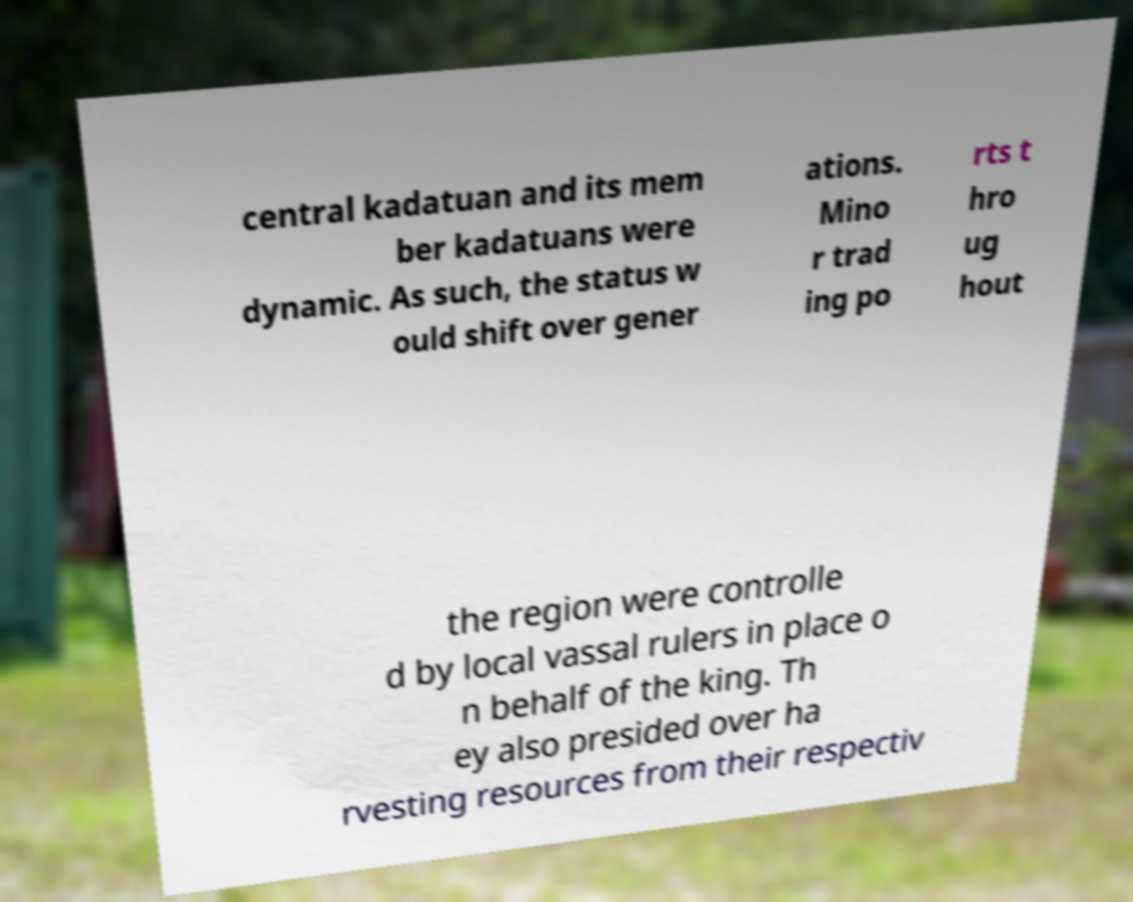There's text embedded in this image that I need extracted. Can you transcribe it verbatim? central kadatuan and its mem ber kadatuans were dynamic. As such, the status w ould shift over gener ations. Mino r trad ing po rts t hro ug hout the region were controlle d by local vassal rulers in place o n behalf of the king. Th ey also presided over ha rvesting resources from their respectiv 